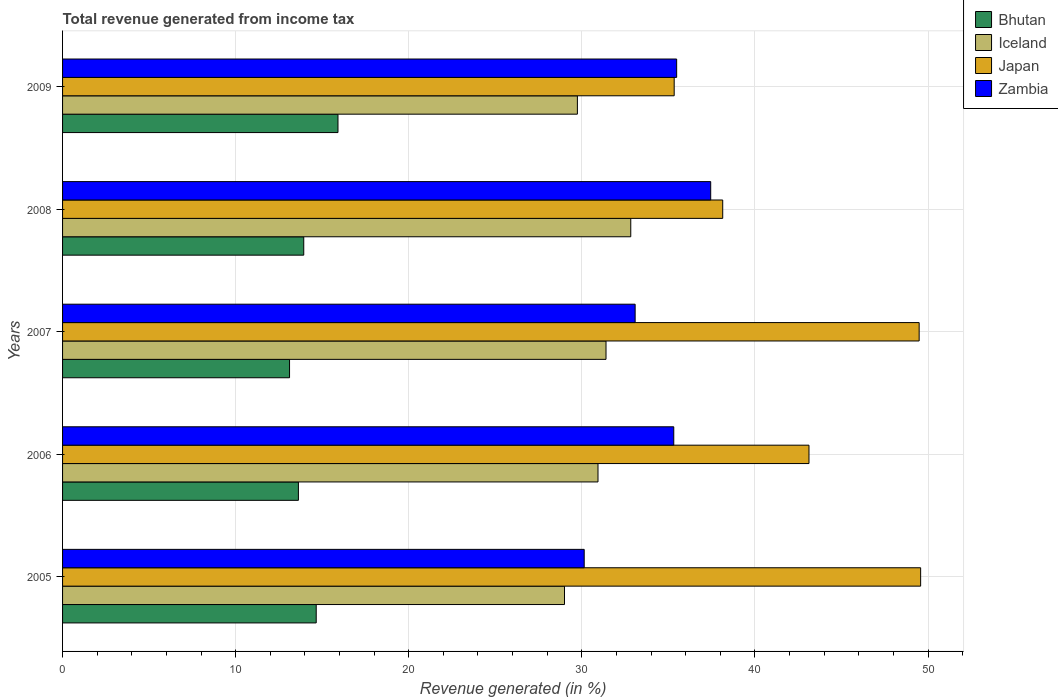How many groups of bars are there?
Your answer should be compact. 5. How many bars are there on the 2nd tick from the top?
Give a very brief answer. 4. How many bars are there on the 3rd tick from the bottom?
Your response must be concise. 4. What is the label of the 1st group of bars from the top?
Keep it short and to the point. 2009. In how many cases, is the number of bars for a given year not equal to the number of legend labels?
Provide a succinct answer. 0. What is the total revenue generated in Zambia in 2005?
Your response must be concise. 30.14. Across all years, what is the maximum total revenue generated in Bhutan?
Your response must be concise. 15.91. Across all years, what is the minimum total revenue generated in Zambia?
Make the answer very short. 30.14. In which year was the total revenue generated in Bhutan maximum?
Keep it short and to the point. 2009. What is the total total revenue generated in Iceland in the graph?
Give a very brief answer. 153.9. What is the difference between the total revenue generated in Zambia in 2007 and that in 2009?
Give a very brief answer. -2.4. What is the difference between the total revenue generated in Bhutan in 2008 and the total revenue generated in Japan in 2007?
Provide a succinct answer. -35.56. What is the average total revenue generated in Zambia per year?
Provide a short and direct response. 34.29. In the year 2006, what is the difference between the total revenue generated in Japan and total revenue generated in Bhutan?
Offer a very short reply. 29.5. What is the ratio of the total revenue generated in Japan in 2005 to that in 2007?
Provide a short and direct response. 1. Is the difference between the total revenue generated in Japan in 2005 and 2008 greater than the difference between the total revenue generated in Bhutan in 2005 and 2008?
Give a very brief answer. Yes. What is the difference between the highest and the second highest total revenue generated in Iceland?
Provide a short and direct response. 1.43. What is the difference between the highest and the lowest total revenue generated in Zambia?
Provide a short and direct response. 7.31. In how many years, is the total revenue generated in Japan greater than the average total revenue generated in Japan taken over all years?
Ensure brevity in your answer.  2. Is the sum of the total revenue generated in Zambia in 2006 and 2009 greater than the maximum total revenue generated in Iceland across all years?
Give a very brief answer. Yes. Is it the case that in every year, the sum of the total revenue generated in Bhutan and total revenue generated in Iceland is greater than the sum of total revenue generated in Japan and total revenue generated in Zambia?
Ensure brevity in your answer.  Yes. What does the 3rd bar from the top in 2008 represents?
Provide a succinct answer. Iceland. What does the 4th bar from the bottom in 2005 represents?
Provide a short and direct response. Zambia. How many bars are there?
Your response must be concise. 20. Are all the bars in the graph horizontal?
Your answer should be compact. Yes. What is the difference between two consecutive major ticks on the X-axis?
Make the answer very short. 10. Where does the legend appear in the graph?
Offer a terse response. Top right. How many legend labels are there?
Your response must be concise. 4. How are the legend labels stacked?
Make the answer very short. Vertical. What is the title of the graph?
Offer a very short reply. Total revenue generated from income tax. What is the label or title of the X-axis?
Keep it short and to the point. Revenue generated (in %). What is the Revenue generated (in %) in Bhutan in 2005?
Make the answer very short. 14.65. What is the Revenue generated (in %) in Iceland in 2005?
Keep it short and to the point. 29. What is the Revenue generated (in %) in Japan in 2005?
Provide a short and direct response. 49.57. What is the Revenue generated (in %) of Zambia in 2005?
Ensure brevity in your answer.  30.14. What is the Revenue generated (in %) in Bhutan in 2006?
Offer a terse response. 13.63. What is the Revenue generated (in %) in Iceland in 2006?
Your answer should be very brief. 30.93. What is the Revenue generated (in %) of Japan in 2006?
Give a very brief answer. 43.12. What is the Revenue generated (in %) in Zambia in 2006?
Provide a short and direct response. 35.31. What is the Revenue generated (in %) of Bhutan in 2007?
Provide a short and direct response. 13.11. What is the Revenue generated (in %) of Iceland in 2007?
Your answer should be very brief. 31.4. What is the Revenue generated (in %) in Japan in 2007?
Offer a very short reply. 49.49. What is the Revenue generated (in %) of Zambia in 2007?
Offer a very short reply. 33.08. What is the Revenue generated (in %) in Bhutan in 2008?
Keep it short and to the point. 13.93. What is the Revenue generated (in %) of Iceland in 2008?
Your answer should be compact. 32.83. What is the Revenue generated (in %) of Japan in 2008?
Your response must be concise. 38.14. What is the Revenue generated (in %) of Zambia in 2008?
Offer a very short reply. 37.45. What is the Revenue generated (in %) of Bhutan in 2009?
Give a very brief answer. 15.91. What is the Revenue generated (in %) of Iceland in 2009?
Your answer should be very brief. 29.74. What is the Revenue generated (in %) of Japan in 2009?
Provide a short and direct response. 35.34. What is the Revenue generated (in %) in Zambia in 2009?
Offer a very short reply. 35.48. Across all years, what is the maximum Revenue generated (in %) of Bhutan?
Offer a very short reply. 15.91. Across all years, what is the maximum Revenue generated (in %) of Iceland?
Offer a very short reply. 32.83. Across all years, what is the maximum Revenue generated (in %) in Japan?
Offer a very short reply. 49.57. Across all years, what is the maximum Revenue generated (in %) of Zambia?
Ensure brevity in your answer.  37.45. Across all years, what is the minimum Revenue generated (in %) in Bhutan?
Offer a very short reply. 13.11. Across all years, what is the minimum Revenue generated (in %) in Iceland?
Provide a succinct answer. 29. Across all years, what is the minimum Revenue generated (in %) in Japan?
Ensure brevity in your answer.  35.34. Across all years, what is the minimum Revenue generated (in %) in Zambia?
Offer a very short reply. 30.14. What is the total Revenue generated (in %) in Bhutan in the graph?
Your answer should be very brief. 71.24. What is the total Revenue generated (in %) of Iceland in the graph?
Provide a short and direct response. 153.9. What is the total Revenue generated (in %) of Japan in the graph?
Offer a very short reply. 215.66. What is the total Revenue generated (in %) of Zambia in the graph?
Your response must be concise. 171.46. What is the difference between the Revenue generated (in %) of Bhutan in 2005 and that in 2006?
Your answer should be compact. 1.03. What is the difference between the Revenue generated (in %) in Iceland in 2005 and that in 2006?
Offer a very short reply. -1.93. What is the difference between the Revenue generated (in %) of Japan in 2005 and that in 2006?
Give a very brief answer. 6.45. What is the difference between the Revenue generated (in %) in Zambia in 2005 and that in 2006?
Your response must be concise. -5.17. What is the difference between the Revenue generated (in %) of Bhutan in 2005 and that in 2007?
Your answer should be very brief. 1.54. What is the difference between the Revenue generated (in %) of Iceland in 2005 and that in 2007?
Provide a short and direct response. -2.4. What is the difference between the Revenue generated (in %) of Japan in 2005 and that in 2007?
Provide a short and direct response. 0.09. What is the difference between the Revenue generated (in %) of Zambia in 2005 and that in 2007?
Your answer should be compact. -2.94. What is the difference between the Revenue generated (in %) of Bhutan in 2005 and that in 2008?
Your answer should be very brief. 0.72. What is the difference between the Revenue generated (in %) of Iceland in 2005 and that in 2008?
Offer a terse response. -3.83. What is the difference between the Revenue generated (in %) in Japan in 2005 and that in 2008?
Make the answer very short. 11.43. What is the difference between the Revenue generated (in %) of Zambia in 2005 and that in 2008?
Provide a succinct answer. -7.31. What is the difference between the Revenue generated (in %) of Bhutan in 2005 and that in 2009?
Provide a succinct answer. -1.26. What is the difference between the Revenue generated (in %) of Iceland in 2005 and that in 2009?
Provide a short and direct response. -0.74. What is the difference between the Revenue generated (in %) of Japan in 2005 and that in 2009?
Offer a terse response. 14.24. What is the difference between the Revenue generated (in %) of Zambia in 2005 and that in 2009?
Make the answer very short. -5.34. What is the difference between the Revenue generated (in %) in Bhutan in 2006 and that in 2007?
Keep it short and to the point. 0.51. What is the difference between the Revenue generated (in %) in Iceland in 2006 and that in 2007?
Provide a succinct answer. -0.46. What is the difference between the Revenue generated (in %) of Japan in 2006 and that in 2007?
Make the answer very short. -6.37. What is the difference between the Revenue generated (in %) of Zambia in 2006 and that in 2007?
Offer a very short reply. 2.23. What is the difference between the Revenue generated (in %) of Bhutan in 2006 and that in 2008?
Provide a succinct answer. -0.31. What is the difference between the Revenue generated (in %) in Iceland in 2006 and that in 2008?
Make the answer very short. -1.89. What is the difference between the Revenue generated (in %) of Japan in 2006 and that in 2008?
Your answer should be very brief. 4.98. What is the difference between the Revenue generated (in %) of Zambia in 2006 and that in 2008?
Provide a succinct answer. -2.13. What is the difference between the Revenue generated (in %) of Bhutan in 2006 and that in 2009?
Offer a terse response. -2.29. What is the difference between the Revenue generated (in %) of Iceland in 2006 and that in 2009?
Your response must be concise. 1.19. What is the difference between the Revenue generated (in %) of Japan in 2006 and that in 2009?
Your response must be concise. 7.79. What is the difference between the Revenue generated (in %) of Zambia in 2006 and that in 2009?
Offer a very short reply. -0.17. What is the difference between the Revenue generated (in %) in Bhutan in 2007 and that in 2008?
Provide a succinct answer. -0.82. What is the difference between the Revenue generated (in %) of Iceland in 2007 and that in 2008?
Offer a very short reply. -1.43. What is the difference between the Revenue generated (in %) of Japan in 2007 and that in 2008?
Ensure brevity in your answer.  11.35. What is the difference between the Revenue generated (in %) in Zambia in 2007 and that in 2008?
Ensure brevity in your answer.  -4.37. What is the difference between the Revenue generated (in %) of Bhutan in 2007 and that in 2009?
Make the answer very short. -2.8. What is the difference between the Revenue generated (in %) of Iceland in 2007 and that in 2009?
Your answer should be compact. 1.65. What is the difference between the Revenue generated (in %) of Japan in 2007 and that in 2009?
Your response must be concise. 14.15. What is the difference between the Revenue generated (in %) in Zambia in 2007 and that in 2009?
Provide a short and direct response. -2.4. What is the difference between the Revenue generated (in %) in Bhutan in 2008 and that in 2009?
Ensure brevity in your answer.  -1.98. What is the difference between the Revenue generated (in %) in Iceland in 2008 and that in 2009?
Make the answer very short. 3.08. What is the difference between the Revenue generated (in %) in Japan in 2008 and that in 2009?
Offer a terse response. 2.8. What is the difference between the Revenue generated (in %) in Zambia in 2008 and that in 2009?
Your answer should be compact. 1.97. What is the difference between the Revenue generated (in %) in Bhutan in 2005 and the Revenue generated (in %) in Iceland in 2006?
Your answer should be compact. -16.28. What is the difference between the Revenue generated (in %) of Bhutan in 2005 and the Revenue generated (in %) of Japan in 2006?
Make the answer very short. -28.47. What is the difference between the Revenue generated (in %) in Bhutan in 2005 and the Revenue generated (in %) in Zambia in 2006?
Give a very brief answer. -20.66. What is the difference between the Revenue generated (in %) in Iceland in 2005 and the Revenue generated (in %) in Japan in 2006?
Offer a terse response. -14.12. What is the difference between the Revenue generated (in %) in Iceland in 2005 and the Revenue generated (in %) in Zambia in 2006?
Keep it short and to the point. -6.31. What is the difference between the Revenue generated (in %) of Japan in 2005 and the Revenue generated (in %) of Zambia in 2006?
Keep it short and to the point. 14.26. What is the difference between the Revenue generated (in %) in Bhutan in 2005 and the Revenue generated (in %) in Iceland in 2007?
Offer a terse response. -16.74. What is the difference between the Revenue generated (in %) in Bhutan in 2005 and the Revenue generated (in %) in Japan in 2007?
Your response must be concise. -34.83. What is the difference between the Revenue generated (in %) of Bhutan in 2005 and the Revenue generated (in %) of Zambia in 2007?
Ensure brevity in your answer.  -18.43. What is the difference between the Revenue generated (in %) in Iceland in 2005 and the Revenue generated (in %) in Japan in 2007?
Make the answer very short. -20.49. What is the difference between the Revenue generated (in %) of Iceland in 2005 and the Revenue generated (in %) of Zambia in 2007?
Keep it short and to the point. -4.08. What is the difference between the Revenue generated (in %) of Japan in 2005 and the Revenue generated (in %) of Zambia in 2007?
Your response must be concise. 16.49. What is the difference between the Revenue generated (in %) in Bhutan in 2005 and the Revenue generated (in %) in Iceland in 2008?
Keep it short and to the point. -18.17. What is the difference between the Revenue generated (in %) in Bhutan in 2005 and the Revenue generated (in %) in Japan in 2008?
Offer a very short reply. -23.49. What is the difference between the Revenue generated (in %) in Bhutan in 2005 and the Revenue generated (in %) in Zambia in 2008?
Give a very brief answer. -22.79. What is the difference between the Revenue generated (in %) of Iceland in 2005 and the Revenue generated (in %) of Japan in 2008?
Offer a terse response. -9.14. What is the difference between the Revenue generated (in %) in Iceland in 2005 and the Revenue generated (in %) in Zambia in 2008?
Provide a short and direct response. -8.45. What is the difference between the Revenue generated (in %) of Japan in 2005 and the Revenue generated (in %) of Zambia in 2008?
Provide a succinct answer. 12.13. What is the difference between the Revenue generated (in %) of Bhutan in 2005 and the Revenue generated (in %) of Iceland in 2009?
Make the answer very short. -15.09. What is the difference between the Revenue generated (in %) of Bhutan in 2005 and the Revenue generated (in %) of Japan in 2009?
Offer a very short reply. -20.68. What is the difference between the Revenue generated (in %) in Bhutan in 2005 and the Revenue generated (in %) in Zambia in 2009?
Offer a terse response. -20.82. What is the difference between the Revenue generated (in %) of Iceland in 2005 and the Revenue generated (in %) of Japan in 2009?
Offer a terse response. -6.34. What is the difference between the Revenue generated (in %) of Iceland in 2005 and the Revenue generated (in %) of Zambia in 2009?
Provide a short and direct response. -6.48. What is the difference between the Revenue generated (in %) of Japan in 2005 and the Revenue generated (in %) of Zambia in 2009?
Give a very brief answer. 14.1. What is the difference between the Revenue generated (in %) of Bhutan in 2006 and the Revenue generated (in %) of Iceland in 2007?
Provide a short and direct response. -17.77. What is the difference between the Revenue generated (in %) in Bhutan in 2006 and the Revenue generated (in %) in Japan in 2007?
Keep it short and to the point. -35.86. What is the difference between the Revenue generated (in %) in Bhutan in 2006 and the Revenue generated (in %) in Zambia in 2007?
Make the answer very short. -19.46. What is the difference between the Revenue generated (in %) of Iceland in 2006 and the Revenue generated (in %) of Japan in 2007?
Your response must be concise. -18.55. What is the difference between the Revenue generated (in %) of Iceland in 2006 and the Revenue generated (in %) of Zambia in 2007?
Keep it short and to the point. -2.15. What is the difference between the Revenue generated (in %) in Japan in 2006 and the Revenue generated (in %) in Zambia in 2007?
Your answer should be compact. 10.04. What is the difference between the Revenue generated (in %) of Bhutan in 2006 and the Revenue generated (in %) of Iceland in 2008?
Offer a very short reply. -19.2. What is the difference between the Revenue generated (in %) in Bhutan in 2006 and the Revenue generated (in %) in Japan in 2008?
Ensure brevity in your answer.  -24.52. What is the difference between the Revenue generated (in %) in Bhutan in 2006 and the Revenue generated (in %) in Zambia in 2008?
Give a very brief answer. -23.82. What is the difference between the Revenue generated (in %) in Iceland in 2006 and the Revenue generated (in %) in Japan in 2008?
Keep it short and to the point. -7.21. What is the difference between the Revenue generated (in %) of Iceland in 2006 and the Revenue generated (in %) of Zambia in 2008?
Provide a short and direct response. -6.51. What is the difference between the Revenue generated (in %) of Japan in 2006 and the Revenue generated (in %) of Zambia in 2008?
Provide a short and direct response. 5.68. What is the difference between the Revenue generated (in %) of Bhutan in 2006 and the Revenue generated (in %) of Iceland in 2009?
Provide a succinct answer. -16.12. What is the difference between the Revenue generated (in %) in Bhutan in 2006 and the Revenue generated (in %) in Japan in 2009?
Give a very brief answer. -21.71. What is the difference between the Revenue generated (in %) of Bhutan in 2006 and the Revenue generated (in %) of Zambia in 2009?
Your response must be concise. -21.85. What is the difference between the Revenue generated (in %) of Iceland in 2006 and the Revenue generated (in %) of Japan in 2009?
Your response must be concise. -4.4. What is the difference between the Revenue generated (in %) of Iceland in 2006 and the Revenue generated (in %) of Zambia in 2009?
Your answer should be very brief. -4.54. What is the difference between the Revenue generated (in %) of Japan in 2006 and the Revenue generated (in %) of Zambia in 2009?
Your response must be concise. 7.64. What is the difference between the Revenue generated (in %) in Bhutan in 2007 and the Revenue generated (in %) in Iceland in 2008?
Provide a short and direct response. -19.71. What is the difference between the Revenue generated (in %) in Bhutan in 2007 and the Revenue generated (in %) in Japan in 2008?
Your response must be concise. -25.03. What is the difference between the Revenue generated (in %) in Bhutan in 2007 and the Revenue generated (in %) in Zambia in 2008?
Provide a succinct answer. -24.33. What is the difference between the Revenue generated (in %) of Iceland in 2007 and the Revenue generated (in %) of Japan in 2008?
Offer a terse response. -6.74. What is the difference between the Revenue generated (in %) in Iceland in 2007 and the Revenue generated (in %) in Zambia in 2008?
Provide a short and direct response. -6.05. What is the difference between the Revenue generated (in %) in Japan in 2007 and the Revenue generated (in %) in Zambia in 2008?
Offer a terse response. 12.04. What is the difference between the Revenue generated (in %) in Bhutan in 2007 and the Revenue generated (in %) in Iceland in 2009?
Your answer should be compact. -16.63. What is the difference between the Revenue generated (in %) of Bhutan in 2007 and the Revenue generated (in %) of Japan in 2009?
Your answer should be compact. -22.22. What is the difference between the Revenue generated (in %) in Bhutan in 2007 and the Revenue generated (in %) in Zambia in 2009?
Your answer should be compact. -22.37. What is the difference between the Revenue generated (in %) of Iceland in 2007 and the Revenue generated (in %) of Japan in 2009?
Provide a succinct answer. -3.94. What is the difference between the Revenue generated (in %) of Iceland in 2007 and the Revenue generated (in %) of Zambia in 2009?
Provide a short and direct response. -4.08. What is the difference between the Revenue generated (in %) of Japan in 2007 and the Revenue generated (in %) of Zambia in 2009?
Your answer should be compact. 14.01. What is the difference between the Revenue generated (in %) in Bhutan in 2008 and the Revenue generated (in %) in Iceland in 2009?
Your answer should be compact. -15.81. What is the difference between the Revenue generated (in %) in Bhutan in 2008 and the Revenue generated (in %) in Japan in 2009?
Make the answer very short. -21.4. What is the difference between the Revenue generated (in %) in Bhutan in 2008 and the Revenue generated (in %) in Zambia in 2009?
Give a very brief answer. -21.55. What is the difference between the Revenue generated (in %) in Iceland in 2008 and the Revenue generated (in %) in Japan in 2009?
Keep it short and to the point. -2.51. What is the difference between the Revenue generated (in %) in Iceland in 2008 and the Revenue generated (in %) in Zambia in 2009?
Offer a very short reply. -2.65. What is the difference between the Revenue generated (in %) of Japan in 2008 and the Revenue generated (in %) of Zambia in 2009?
Your answer should be very brief. 2.66. What is the average Revenue generated (in %) in Bhutan per year?
Make the answer very short. 14.25. What is the average Revenue generated (in %) in Iceland per year?
Your answer should be very brief. 30.78. What is the average Revenue generated (in %) of Japan per year?
Keep it short and to the point. 43.13. What is the average Revenue generated (in %) of Zambia per year?
Make the answer very short. 34.29. In the year 2005, what is the difference between the Revenue generated (in %) of Bhutan and Revenue generated (in %) of Iceland?
Provide a short and direct response. -14.34. In the year 2005, what is the difference between the Revenue generated (in %) of Bhutan and Revenue generated (in %) of Japan?
Ensure brevity in your answer.  -34.92. In the year 2005, what is the difference between the Revenue generated (in %) in Bhutan and Revenue generated (in %) in Zambia?
Provide a succinct answer. -15.48. In the year 2005, what is the difference between the Revenue generated (in %) in Iceland and Revenue generated (in %) in Japan?
Keep it short and to the point. -20.58. In the year 2005, what is the difference between the Revenue generated (in %) of Iceland and Revenue generated (in %) of Zambia?
Your answer should be very brief. -1.14. In the year 2005, what is the difference between the Revenue generated (in %) in Japan and Revenue generated (in %) in Zambia?
Provide a short and direct response. 19.44. In the year 2006, what is the difference between the Revenue generated (in %) in Bhutan and Revenue generated (in %) in Iceland?
Ensure brevity in your answer.  -17.31. In the year 2006, what is the difference between the Revenue generated (in %) in Bhutan and Revenue generated (in %) in Japan?
Offer a terse response. -29.5. In the year 2006, what is the difference between the Revenue generated (in %) in Bhutan and Revenue generated (in %) in Zambia?
Your answer should be compact. -21.69. In the year 2006, what is the difference between the Revenue generated (in %) in Iceland and Revenue generated (in %) in Japan?
Ensure brevity in your answer.  -12.19. In the year 2006, what is the difference between the Revenue generated (in %) of Iceland and Revenue generated (in %) of Zambia?
Provide a succinct answer. -4.38. In the year 2006, what is the difference between the Revenue generated (in %) in Japan and Revenue generated (in %) in Zambia?
Provide a succinct answer. 7.81. In the year 2007, what is the difference between the Revenue generated (in %) of Bhutan and Revenue generated (in %) of Iceland?
Ensure brevity in your answer.  -18.28. In the year 2007, what is the difference between the Revenue generated (in %) of Bhutan and Revenue generated (in %) of Japan?
Offer a very short reply. -36.38. In the year 2007, what is the difference between the Revenue generated (in %) in Bhutan and Revenue generated (in %) in Zambia?
Offer a very short reply. -19.97. In the year 2007, what is the difference between the Revenue generated (in %) of Iceland and Revenue generated (in %) of Japan?
Your response must be concise. -18.09. In the year 2007, what is the difference between the Revenue generated (in %) in Iceland and Revenue generated (in %) in Zambia?
Ensure brevity in your answer.  -1.68. In the year 2007, what is the difference between the Revenue generated (in %) of Japan and Revenue generated (in %) of Zambia?
Your answer should be very brief. 16.41. In the year 2008, what is the difference between the Revenue generated (in %) in Bhutan and Revenue generated (in %) in Iceland?
Offer a very short reply. -18.89. In the year 2008, what is the difference between the Revenue generated (in %) of Bhutan and Revenue generated (in %) of Japan?
Offer a terse response. -24.21. In the year 2008, what is the difference between the Revenue generated (in %) in Bhutan and Revenue generated (in %) in Zambia?
Keep it short and to the point. -23.51. In the year 2008, what is the difference between the Revenue generated (in %) of Iceland and Revenue generated (in %) of Japan?
Ensure brevity in your answer.  -5.31. In the year 2008, what is the difference between the Revenue generated (in %) in Iceland and Revenue generated (in %) in Zambia?
Ensure brevity in your answer.  -4.62. In the year 2008, what is the difference between the Revenue generated (in %) of Japan and Revenue generated (in %) of Zambia?
Provide a short and direct response. 0.69. In the year 2009, what is the difference between the Revenue generated (in %) of Bhutan and Revenue generated (in %) of Iceland?
Make the answer very short. -13.83. In the year 2009, what is the difference between the Revenue generated (in %) in Bhutan and Revenue generated (in %) in Japan?
Your answer should be compact. -19.42. In the year 2009, what is the difference between the Revenue generated (in %) in Bhutan and Revenue generated (in %) in Zambia?
Make the answer very short. -19.57. In the year 2009, what is the difference between the Revenue generated (in %) of Iceland and Revenue generated (in %) of Japan?
Ensure brevity in your answer.  -5.59. In the year 2009, what is the difference between the Revenue generated (in %) in Iceland and Revenue generated (in %) in Zambia?
Ensure brevity in your answer.  -5.74. In the year 2009, what is the difference between the Revenue generated (in %) of Japan and Revenue generated (in %) of Zambia?
Offer a very short reply. -0.14. What is the ratio of the Revenue generated (in %) in Bhutan in 2005 to that in 2006?
Give a very brief answer. 1.08. What is the ratio of the Revenue generated (in %) in Iceland in 2005 to that in 2006?
Offer a terse response. 0.94. What is the ratio of the Revenue generated (in %) of Japan in 2005 to that in 2006?
Provide a short and direct response. 1.15. What is the ratio of the Revenue generated (in %) in Zambia in 2005 to that in 2006?
Your response must be concise. 0.85. What is the ratio of the Revenue generated (in %) of Bhutan in 2005 to that in 2007?
Offer a terse response. 1.12. What is the ratio of the Revenue generated (in %) of Iceland in 2005 to that in 2007?
Provide a succinct answer. 0.92. What is the ratio of the Revenue generated (in %) in Japan in 2005 to that in 2007?
Keep it short and to the point. 1. What is the ratio of the Revenue generated (in %) in Zambia in 2005 to that in 2007?
Your answer should be compact. 0.91. What is the ratio of the Revenue generated (in %) in Bhutan in 2005 to that in 2008?
Offer a terse response. 1.05. What is the ratio of the Revenue generated (in %) in Iceland in 2005 to that in 2008?
Offer a very short reply. 0.88. What is the ratio of the Revenue generated (in %) of Japan in 2005 to that in 2008?
Provide a succinct answer. 1.3. What is the ratio of the Revenue generated (in %) of Zambia in 2005 to that in 2008?
Make the answer very short. 0.8. What is the ratio of the Revenue generated (in %) of Bhutan in 2005 to that in 2009?
Keep it short and to the point. 0.92. What is the ratio of the Revenue generated (in %) of Iceland in 2005 to that in 2009?
Offer a terse response. 0.97. What is the ratio of the Revenue generated (in %) in Japan in 2005 to that in 2009?
Your response must be concise. 1.4. What is the ratio of the Revenue generated (in %) of Zambia in 2005 to that in 2009?
Your answer should be very brief. 0.85. What is the ratio of the Revenue generated (in %) in Bhutan in 2006 to that in 2007?
Provide a succinct answer. 1.04. What is the ratio of the Revenue generated (in %) of Iceland in 2006 to that in 2007?
Offer a terse response. 0.99. What is the ratio of the Revenue generated (in %) in Japan in 2006 to that in 2007?
Offer a terse response. 0.87. What is the ratio of the Revenue generated (in %) of Zambia in 2006 to that in 2007?
Make the answer very short. 1.07. What is the ratio of the Revenue generated (in %) of Bhutan in 2006 to that in 2008?
Your response must be concise. 0.98. What is the ratio of the Revenue generated (in %) in Iceland in 2006 to that in 2008?
Offer a terse response. 0.94. What is the ratio of the Revenue generated (in %) in Japan in 2006 to that in 2008?
Offer a very short reply. 1.13. What is the ratio of the Revenue generated (in %) of Zambia in 2006 to that in 2008?
Give a very brief answer. 0.94. What is the ratio of the Revenue generated (in %) of Bhutan in 2006 to that in 2009?
Ensure brevity in your answer.  0.86. What is the ratio of the Revenue generated (in %) in Japan in 2006 to that in 2009?
Provide a succinct answer. 1.22. What is the ratio of the Revenue generated (in %) in Bhutan in 2007 to that in 2008?
Make the answer very short. 0.94. What is the ratio of the Revenue generated (in %) of Iceland in 2007 to that in 2008?
Offer a terse response. 0.96. What is the ratio of the Revenue generated (in %) in Japan in 2007 to that in 2008?
Ensure brevity in your answer.  1.3. What is the ratio of the Revenue generated (in %) in Zambia in 2007 to that in 2008?
Your answer should be compact. 0.88. What is the ratio of the Revenue generated (in %) in Bhutan in 2007 to that in 2009?
Make the answer very short. 0.82. What is the ratio of the Revenue generated (in %) in Iceland in 2007 to that in 2009?
Provide a short and direct response. 1.06. What is the ratio of the Revenue generated (in %) in Japan in 2007 to that in 2009?
Make the answer very short. 1.4. What is the ratio of the Revenue generated (in %) in Zambia in 2007 to that in 2009?
Your answer should be very brief. 0.93. What is the ratio of the Revenue generated (in %) of Bhutan in 2008 to that in 2009?
Ensure brevity in your answer.  0.88. What is the ratio of the Revenue generated (in %) of Iceland in 2008 to that in 2009?
Offer a terse response. 1.1. What is the ratio of the Revenue generated (in %) of Japan in 2008 to that in 2009?
Keep it short and to the point. 1.08. What is the ratio of the Revenue generated (in %) in Zambia in 2008 to that in 2009?
Your response must be concise. 1.06. What is the difference between the highest and the second highest Revenue generated (in %) in Bhutan?
Give a very brief answer. 1.26. What is the difference between the highest and the second highest Revenue generated (in %) in Iceland?
Make the answer very short. 1.43. What is the difference between the highest and the second highest Revenue generated (in %) in Japan?
Make the answer very short. 0.09. What is the difference between the highest and the second highest Revenue generated (in %) in Zambia?
Give a very brief answer. 1.97. What is the difference between the highest and the lowest Revenue generated (in %) in Bhutan?
Offer a very short reply. 2.8. What is the difference between the highest and the lowest Revenue generated (in %) in Iceland?
Your answer should be compact. 3.83. What is the difference between the highest and the lowest Revenue generated (in %) of Japan?
Keep it short and to the point. 14.24. What is the difference between the highest and the lowest Revenue generated (in %) in Zambia?
Offer a terse response. 7.31. 